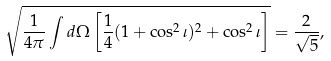Convert formula to latex. <formula><loc_0><loc_0><loc_500><loc_500>\sqrt { \frac { 1 } { 4 \pi } \int d \Omega \left [ \frac { 1 } { 4 } ( 1 + \cos ^ { 2 } \iota ) ^ { 2 } + \cos ^ { 2 } \iota \right ] } = \frac { 2 } { \sqrt { 5 } } ,</formula> 